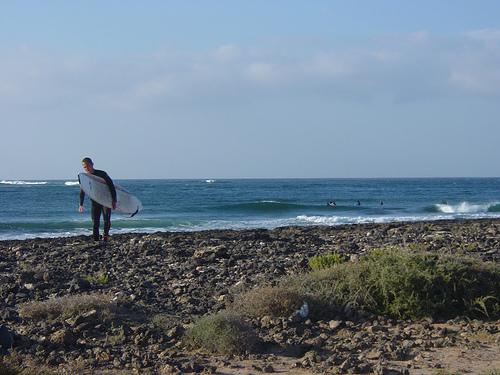Question: who does the person in photo appear to be?
Choices:
A. My mom.
B. Man.
C. The pope.
D. Shelly.
Answer with the letter. Answer: B Question: what is the man carrying?
Choices:
A. A bag.
B. A body.
C. Surfboard.
D. His mom.
Answer with the letter. Answer: C Question: where was this photo taken?
Choices:
A. Beach.
B. Mountains.
C. A valley.
D. Outer space.
Answer with the letter. Answer: A Question: what color does the man's wetsuit appear to be?
Choices:
A. Black.
B. White.
C. Silver.
D. Red.
Answer with the letter. Answer: A 